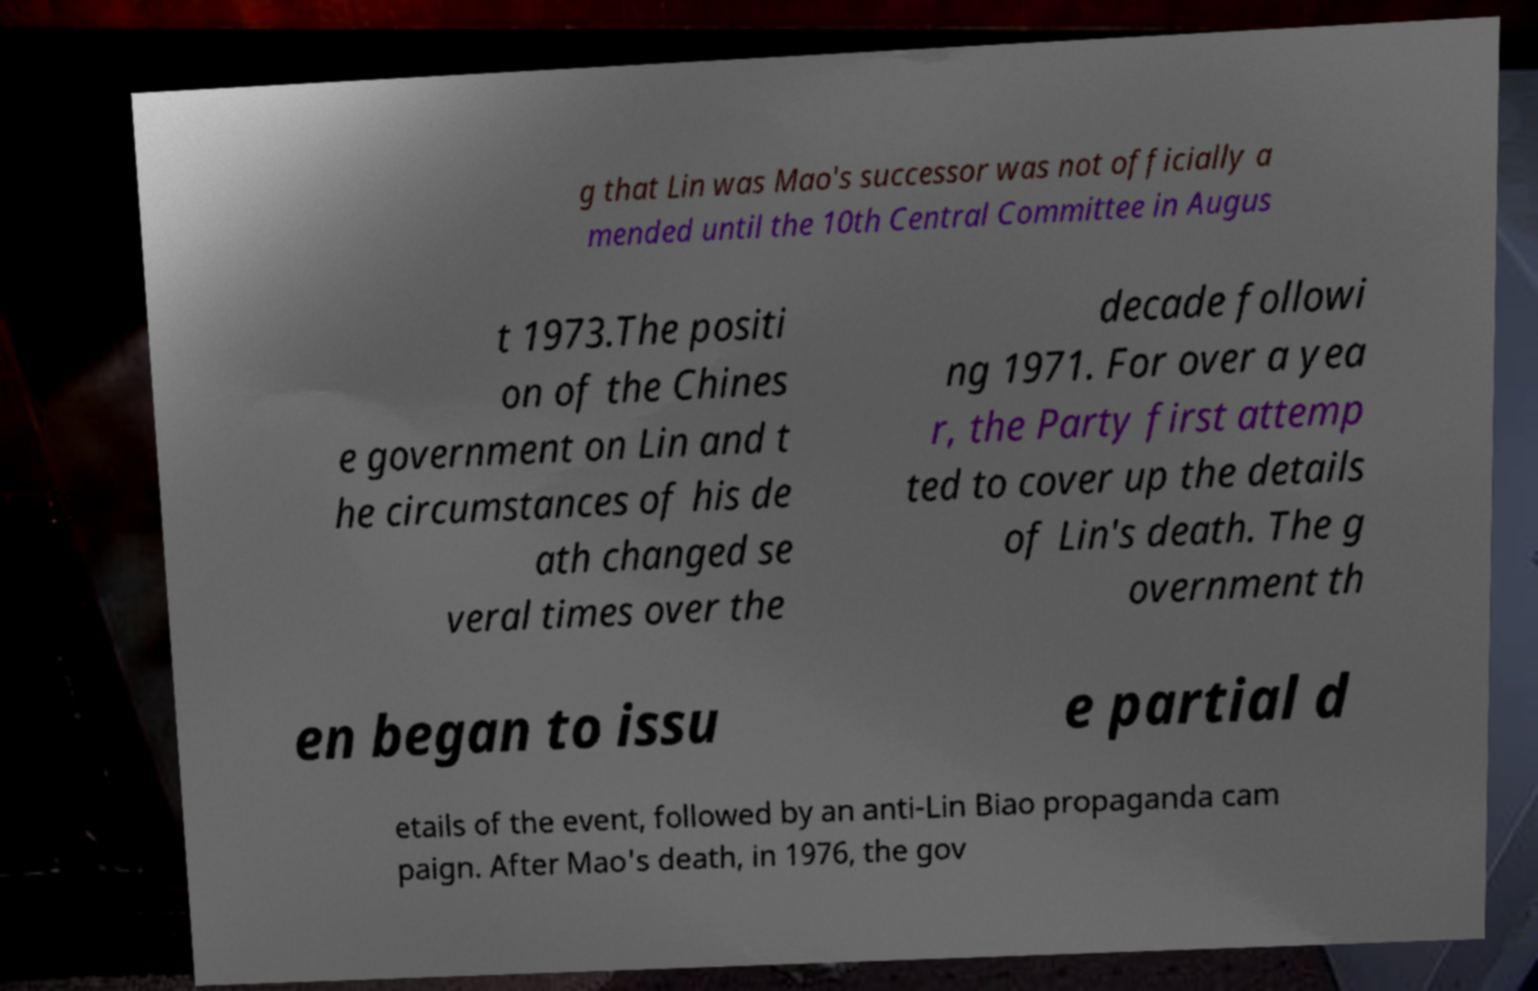Could you assist in decoding the text presented in this image and type it out clearly? g that Lin was Mao's successor was not officially a mended until the 10th Central Committee in Augus t 1973.The positi on of the Chines e government on Lin and t he circumstances of his de ath changed se veral times over the decade followi ng 1971. For over a yea r, the Party first attemp ted to cover up the details of Lin's death. The g overnment th en began to issu e partial d etails of the event, followed by an anti-Lin Biao propaganda cam paign. After Mao's death, in 1976, the gov 